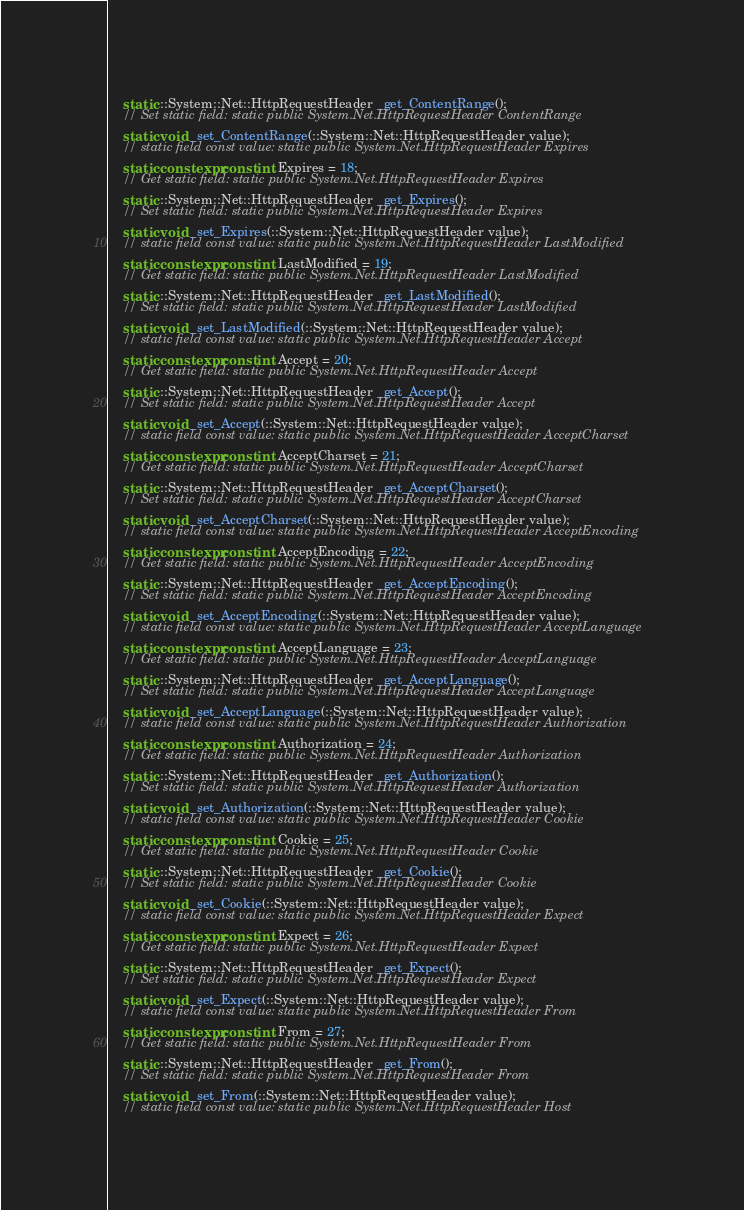Convert code to text. <code><loc_0><loc_0><loc_500><loc_500><_C++_>    static ::System::Net::HttpRequestHeader _get_ContentRange();
    // Set static field: static public System.Net.HttpRequestHeader ContentRange
    static void _set_ContentRange(::System::Net::HttpRequestHeader value);
    // static field const value: static public System.Net.HttpRequestHeader Expires
    static constexpr const int Expires = 18;
    // Get static field: static public System.Net.HttpRequestHeader Expires
    static ::System::Net::HttpRequestHeader _get_Expires();
    // Set static field: static public System.Net.HttpRequestHeader Expires
    static void _set_Expires(::System::Net::HttpRequestHeader value);
    // static field const value: static public System.Net.HttpRequestHeader LastModified
    static constexpr const int LastModified = 19;
    // Get static field: static public System.Net.HttpRequestHeader LastModified
    static ::System::Net::HttpRequestHeader _get_LastModified();
    // Set static field: static public System.Net.HttpRequestHeader LastModified
    static void _set_LastModified(::System::Net::HttpRequestHeader value);
    // static field const value: static public System.Net.HttpRequestHeader Accept
    static constexpr const int Accept = 20;
    // Get static field: static public System.Net.HttpRequestHeader Accept
    static ::System::Net::HttpRequestHeader _get_Accept();
    // Set static field: static public System.Net.HttpRequestHeader Accept
    static void _set_Accept(::System::Net::HttpRequestHeader value);
    // static field const value: static public System.Net.HttpRequestHeader AcceptCharset
    static constexpr const int AcceptCharset = 21;
    // Get static field: static public System.Net.HttpRequestHeader AcceptCharset
    static ::System::Net::HttpRequestHeader _get_AcceptCharset();
    // Set static field: static public System.Net.HttpRequestHeader AcceptCharset
    static void _set_AcceptCharset(::System::Net::HttpRequestHeader value);
    // static field const value: static public System.Net.HttpRequestHeader AcceptEncoding
    static constexpr const int AcceptEncoding = 22;
    // Get static field: static public System.Net.HttpRequestHeader AcceptEncoding
    static ::System::Net::HttpRequestHeader _get_AcceptEncoding();
    // Set static field: static public System.Net.HttpRequestHeader AcceptEncoding
    static void _set_AcceptEncoding(::System::Net::HttpRequestHeader value);
    // static field const value: static public System.Net.HttpRequestHeader AcceptLanguage
    static constexpr const int AcceptLanguage = 23;
    // Get static field: static public System.Net.HttpRequestHeader AcceptLanguage
    static ::System::Net::HttpRequestHeader _get_AcceptLanguage();
    // Set static field: static public System.Net.HttpRequestHeader AcceptLanguage
    static void _set_AcceptLanguage(::System::Net::HttpRequestHeader value);
    // static field const value: static public System.Net.HttpRequestHeader Authorization
    static constexpr const int Authorization = 24;
    // Get static field: static public System.Net.HttpRequestHeader Authorization
    static ::System::Net::HttpRequestHeader _get_Authorization();
    // Set static field: static public System.Net.HttpRequestHeader Authorization
    static void _set_Authorization(::System::Net::HttpRequestHeader value);
    // static field const value: static public System.Net.HttpRequestHeader Cookie
    static constexpr const int Cookie = 25;
    // Get static field: static public System.Net.HttpRequestHeader Cookie
    static ::System::Net::HttpRequestHeader _get_Cookie();
    // Set static field: static public System.Net.HttpRequestHeader Cookie
    static void _set_Cookie(::System::Net::HttpRequestHeader value);
    // static field const value: static public System.Net.HttpRequestHeader Expect
    static constexpr const int Expect = 26;
    // Get static field: static public System.Net.HttpRequestHeader Expect
    static ::System::Net::HttpRequestHeader _get_Expect();
    // Set static field: static public System.Net.HttpRequestHeader Expect
    static void _set_Expect(::System::Net::HttpRequestHeader value);
    // static field const value: static public System.Net.HttpRequestHeader From
    static constexpr const int From = 27;
    // Get static field: static public System.Net.HttpRequestHeader From
    static ::System::Net::HttpRequestHeader _get_From();
    // Set static field: static public System.Net.HttpRequestHeader From
    static void _set_From(::System::Net::HttpRequestHeader value);
    // static field const value: static public System.Net.HttpRequestHeader Host</code> 